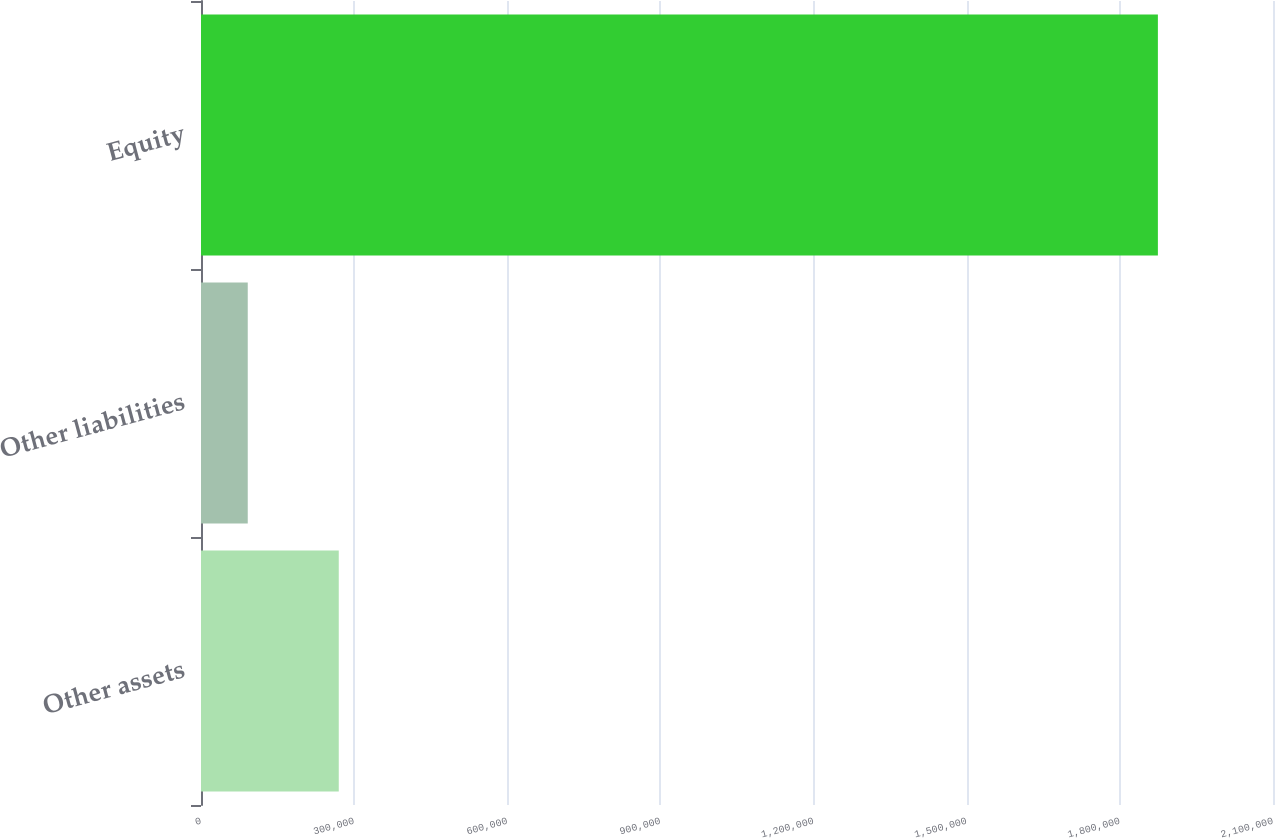Convert chart. <chart><loc_0><loc_0><loc_500><loc_500><bar_chart><fcel>Other assets<fcel>Other liabilities<fcel>Equity<nl><fcel>269871<fcel>91579<fcel>1.8745e+06<nl></chart> 